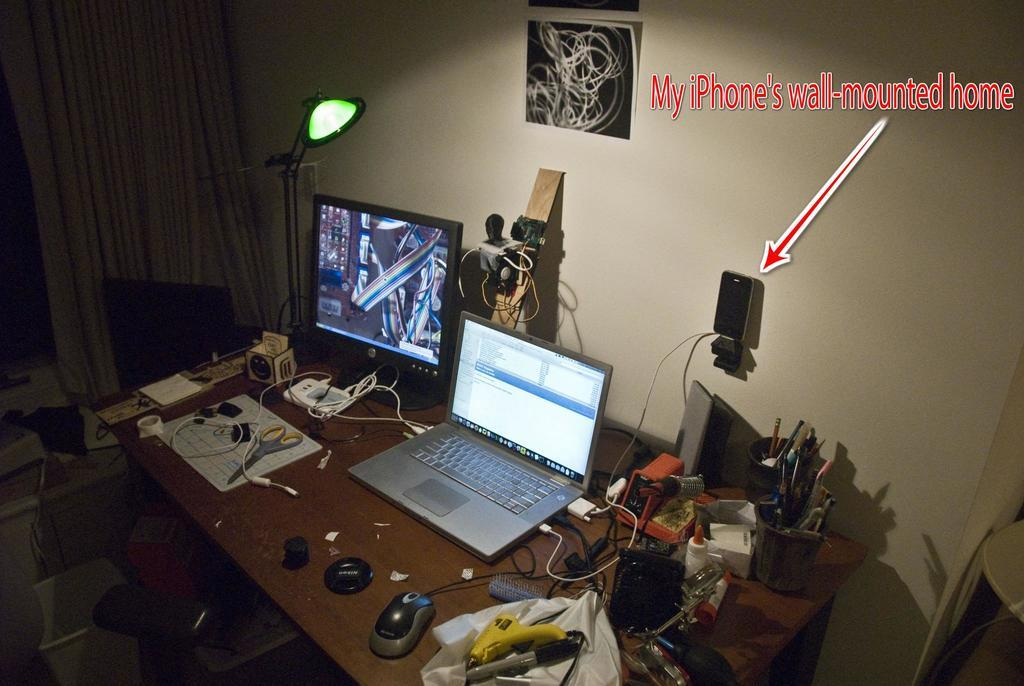<image>
Present a compact description of the photo's key features. A clustered desk with a computer monitor and laptop with a note pointing out an Iphone wall mount. 